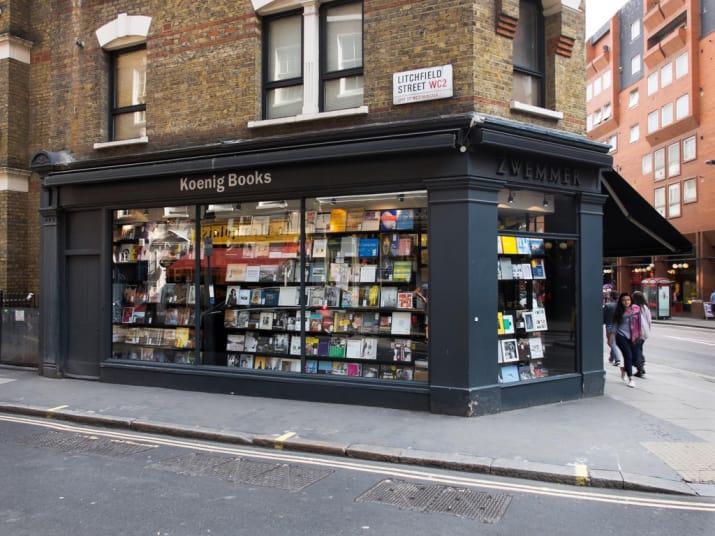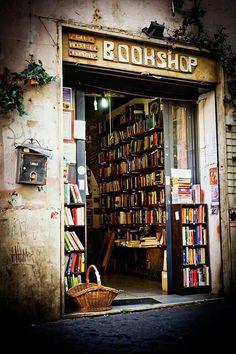The first image is the image on the left, the second image is the image on the right. Evaluate the accuracy of this statement regarding the images: "Both images include book shop exteriors.". Is it true? Answer yes or no. Yes. The first image is the image on the left, the second image is the image on the right. For the images shown, is this caption "In one image, at least one person is inside a book store that has books shelved to the ceiling." true? Answer yes or no. No. 